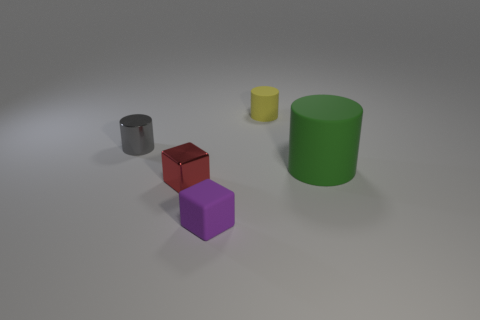Add 4 red things. How many objects exist? 9 Subtract all cylinders. How many objects are left? 2 Add 5 green matte cubes. How many green matte cubes exist? 5 Subtract 0 gray balls. How many objects are left? 5 Subtract all red objects. Subtract all yellow cylinders. How many objects are left? 3 Add 4 yellow things. How many yellow things are left? 5 